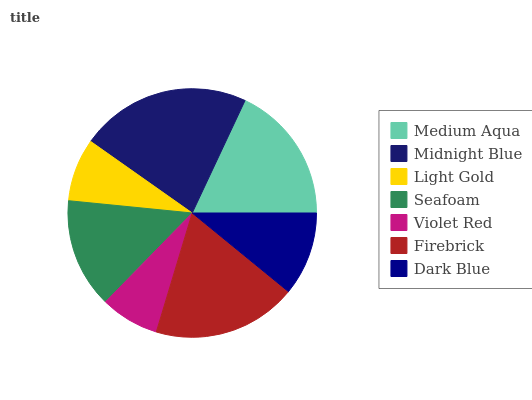Is Violet Red the minimum?
Answer yes or no. Yes. Is Midnight Blue the maximum?
Answer yes or no. Yes. Is Light Gold the minimum?
Answer yes or no. No. Is Light Gold the maximum?
Answer yes or no. No. Is Midnight Blue greater than Light Gold?
Answer yes or no. Yes. Is Light Gold less than Midnight Blue?
Answer yes or no. Yes. Is Light Gold greater than Midnight Blue?
Answer yes or no. No. Is Midnight Blue less than Light Gold?
Answer yes or no. No. Is Seafoam the high median?
Answer yes or no. Yes. Is Seafoam the low median?
Answer yes or no. Yes. Is Light Gold the high median?
Answer yes or no. No. Is Firebrick the low median?
Answer yes or no. No. 